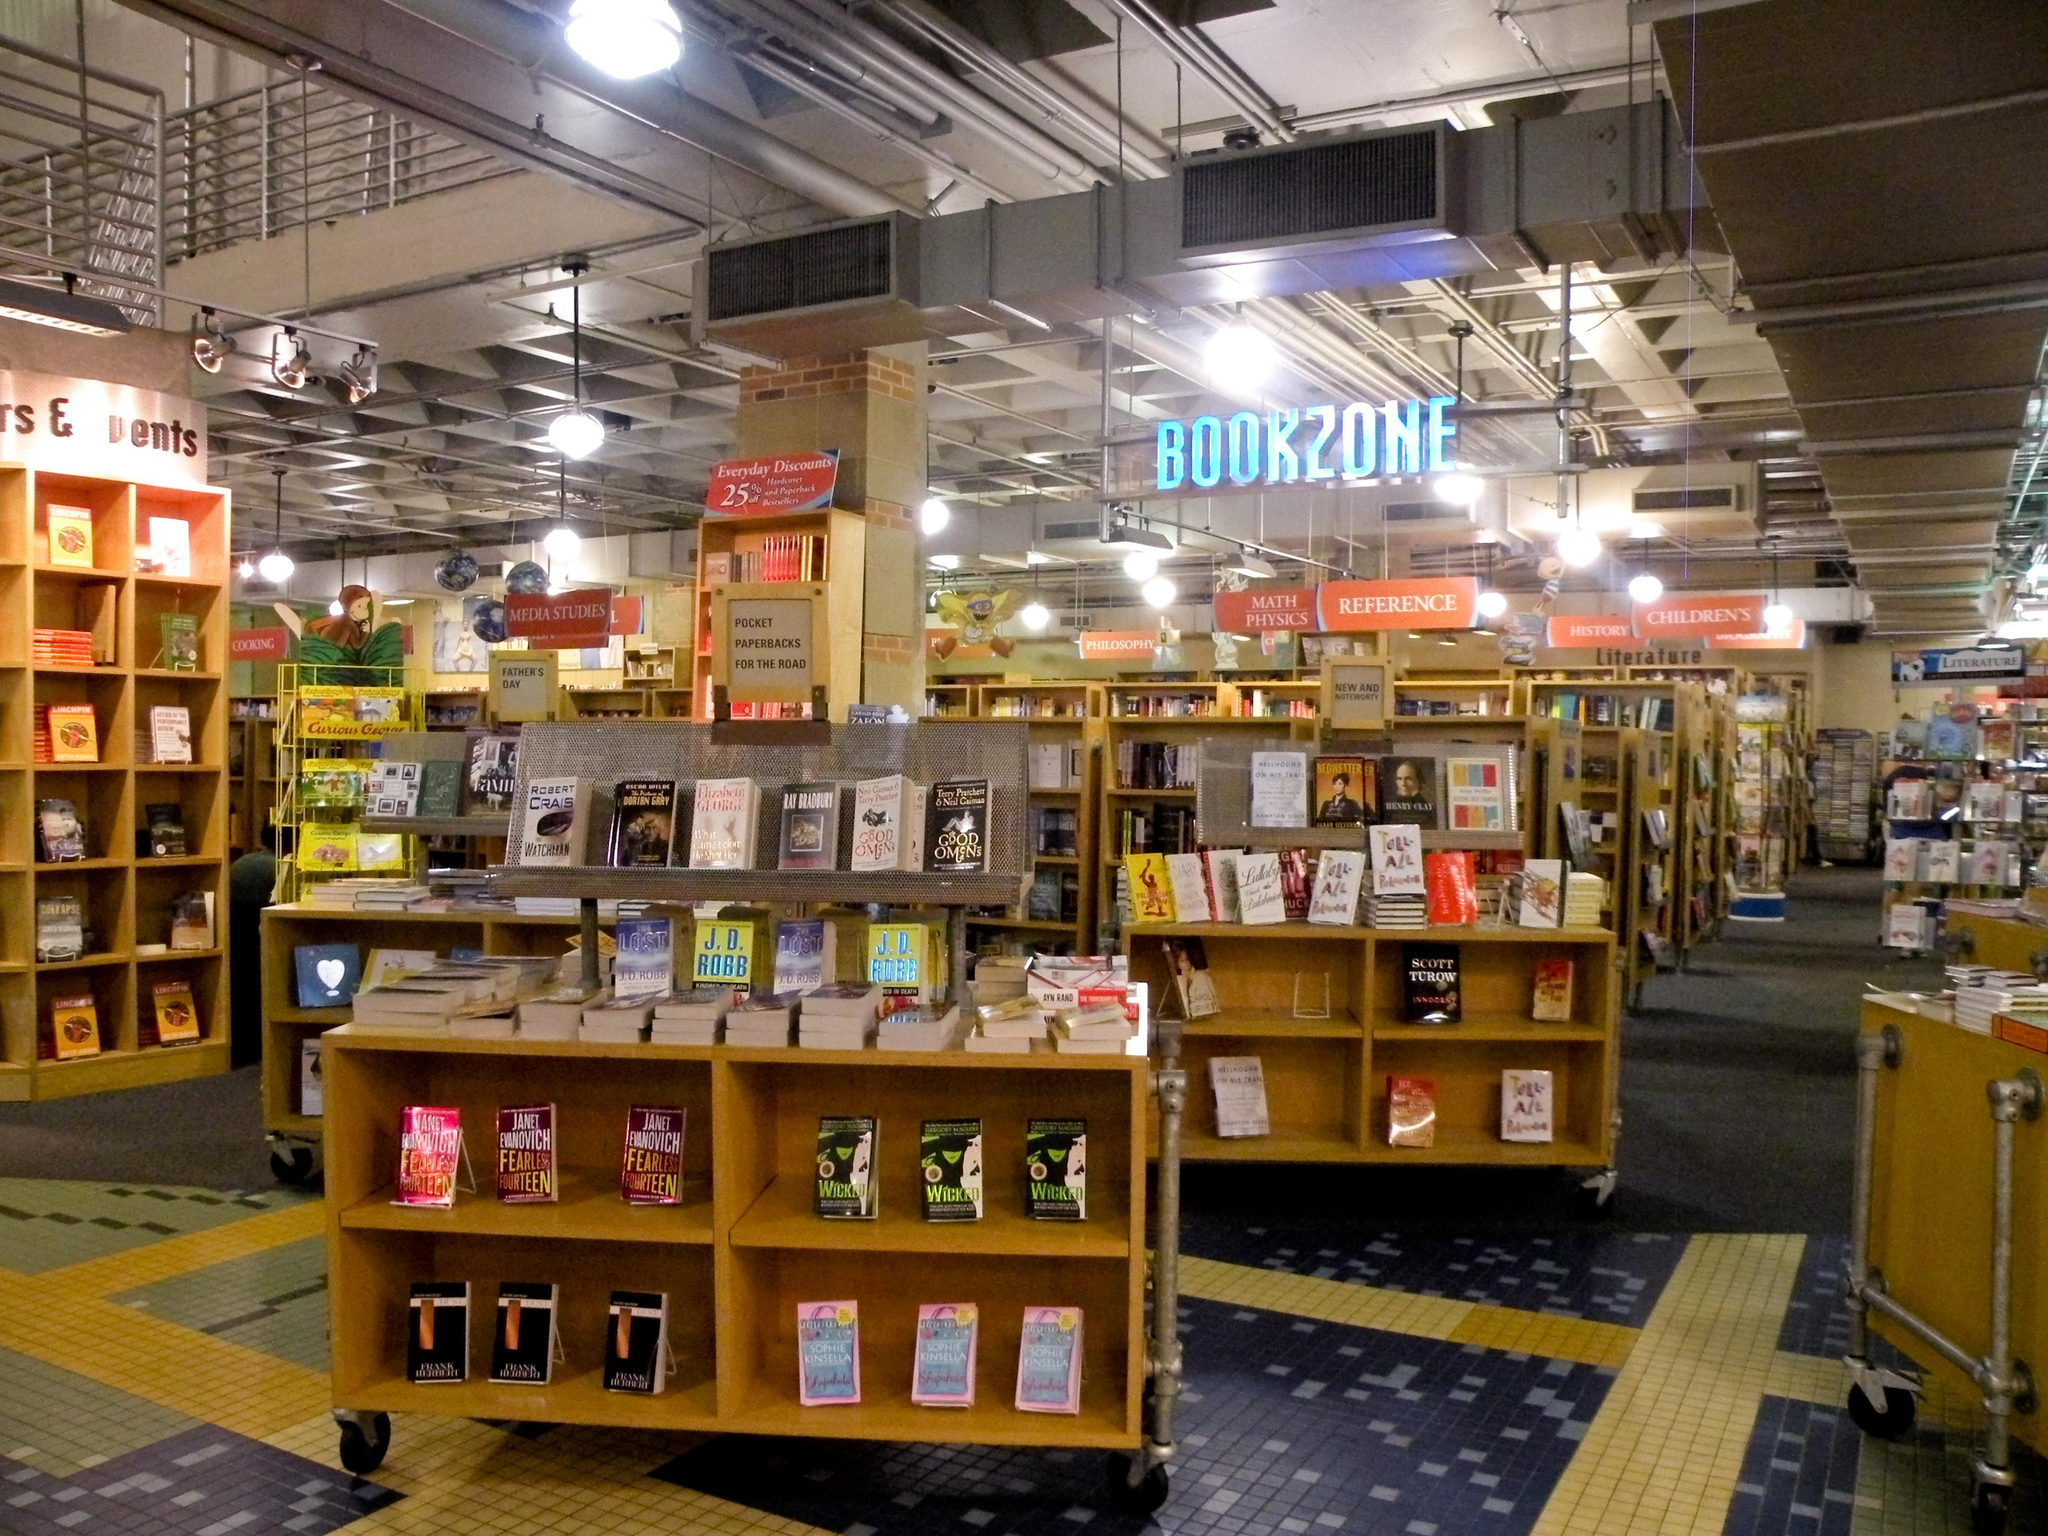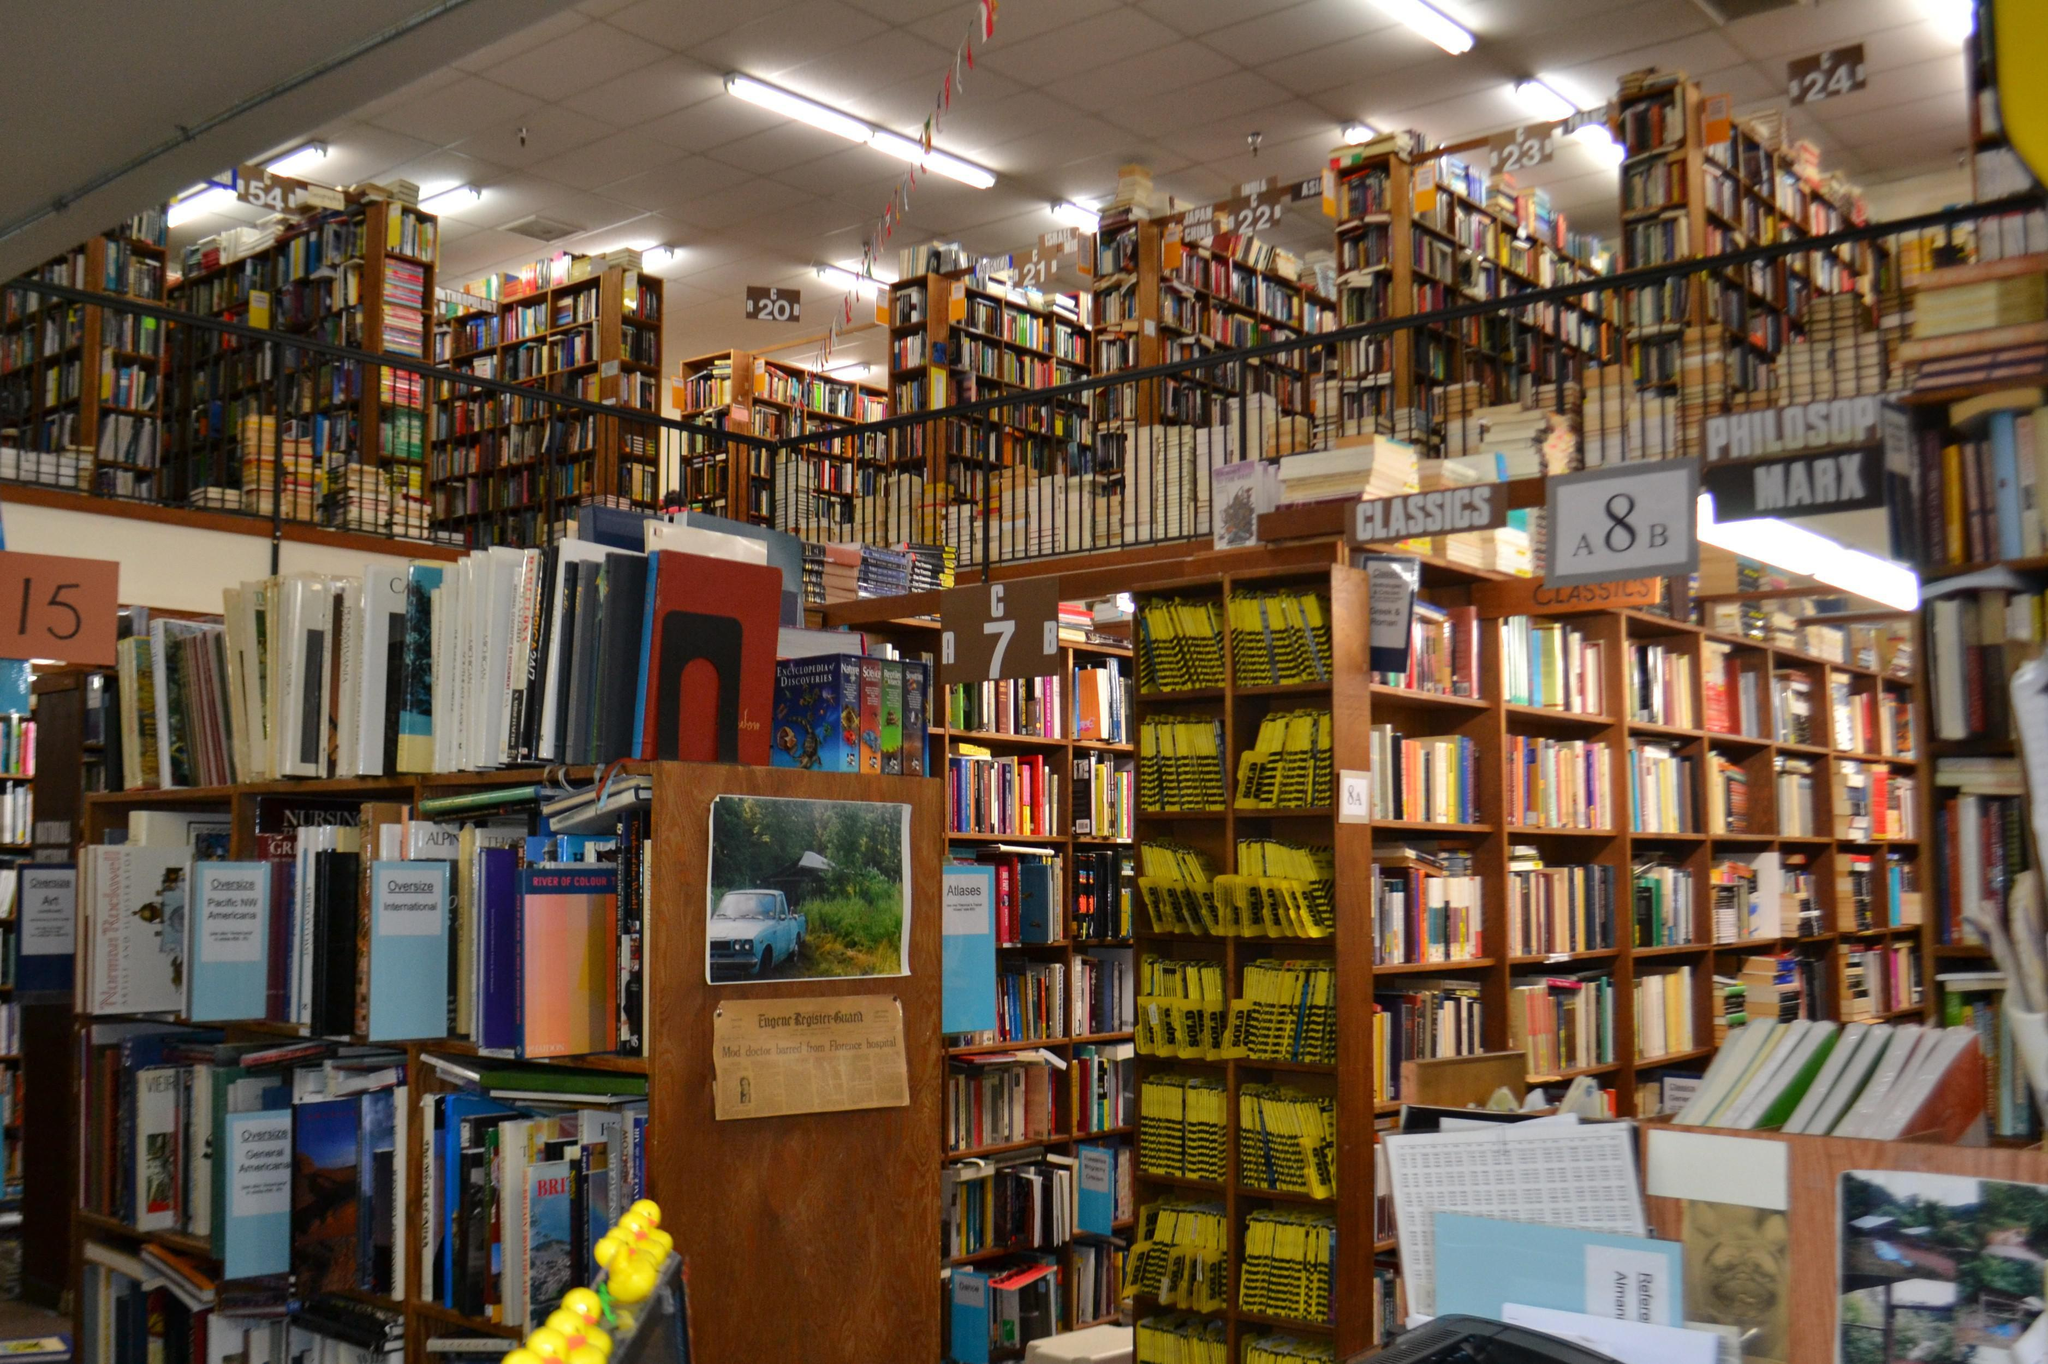The first image is the image on the left, the second image is the image on the right. Evaluate the accuracy of this statement regarding the images: "There are at least two people in the image on the right.". Is it true? Answer yes or no. No. 